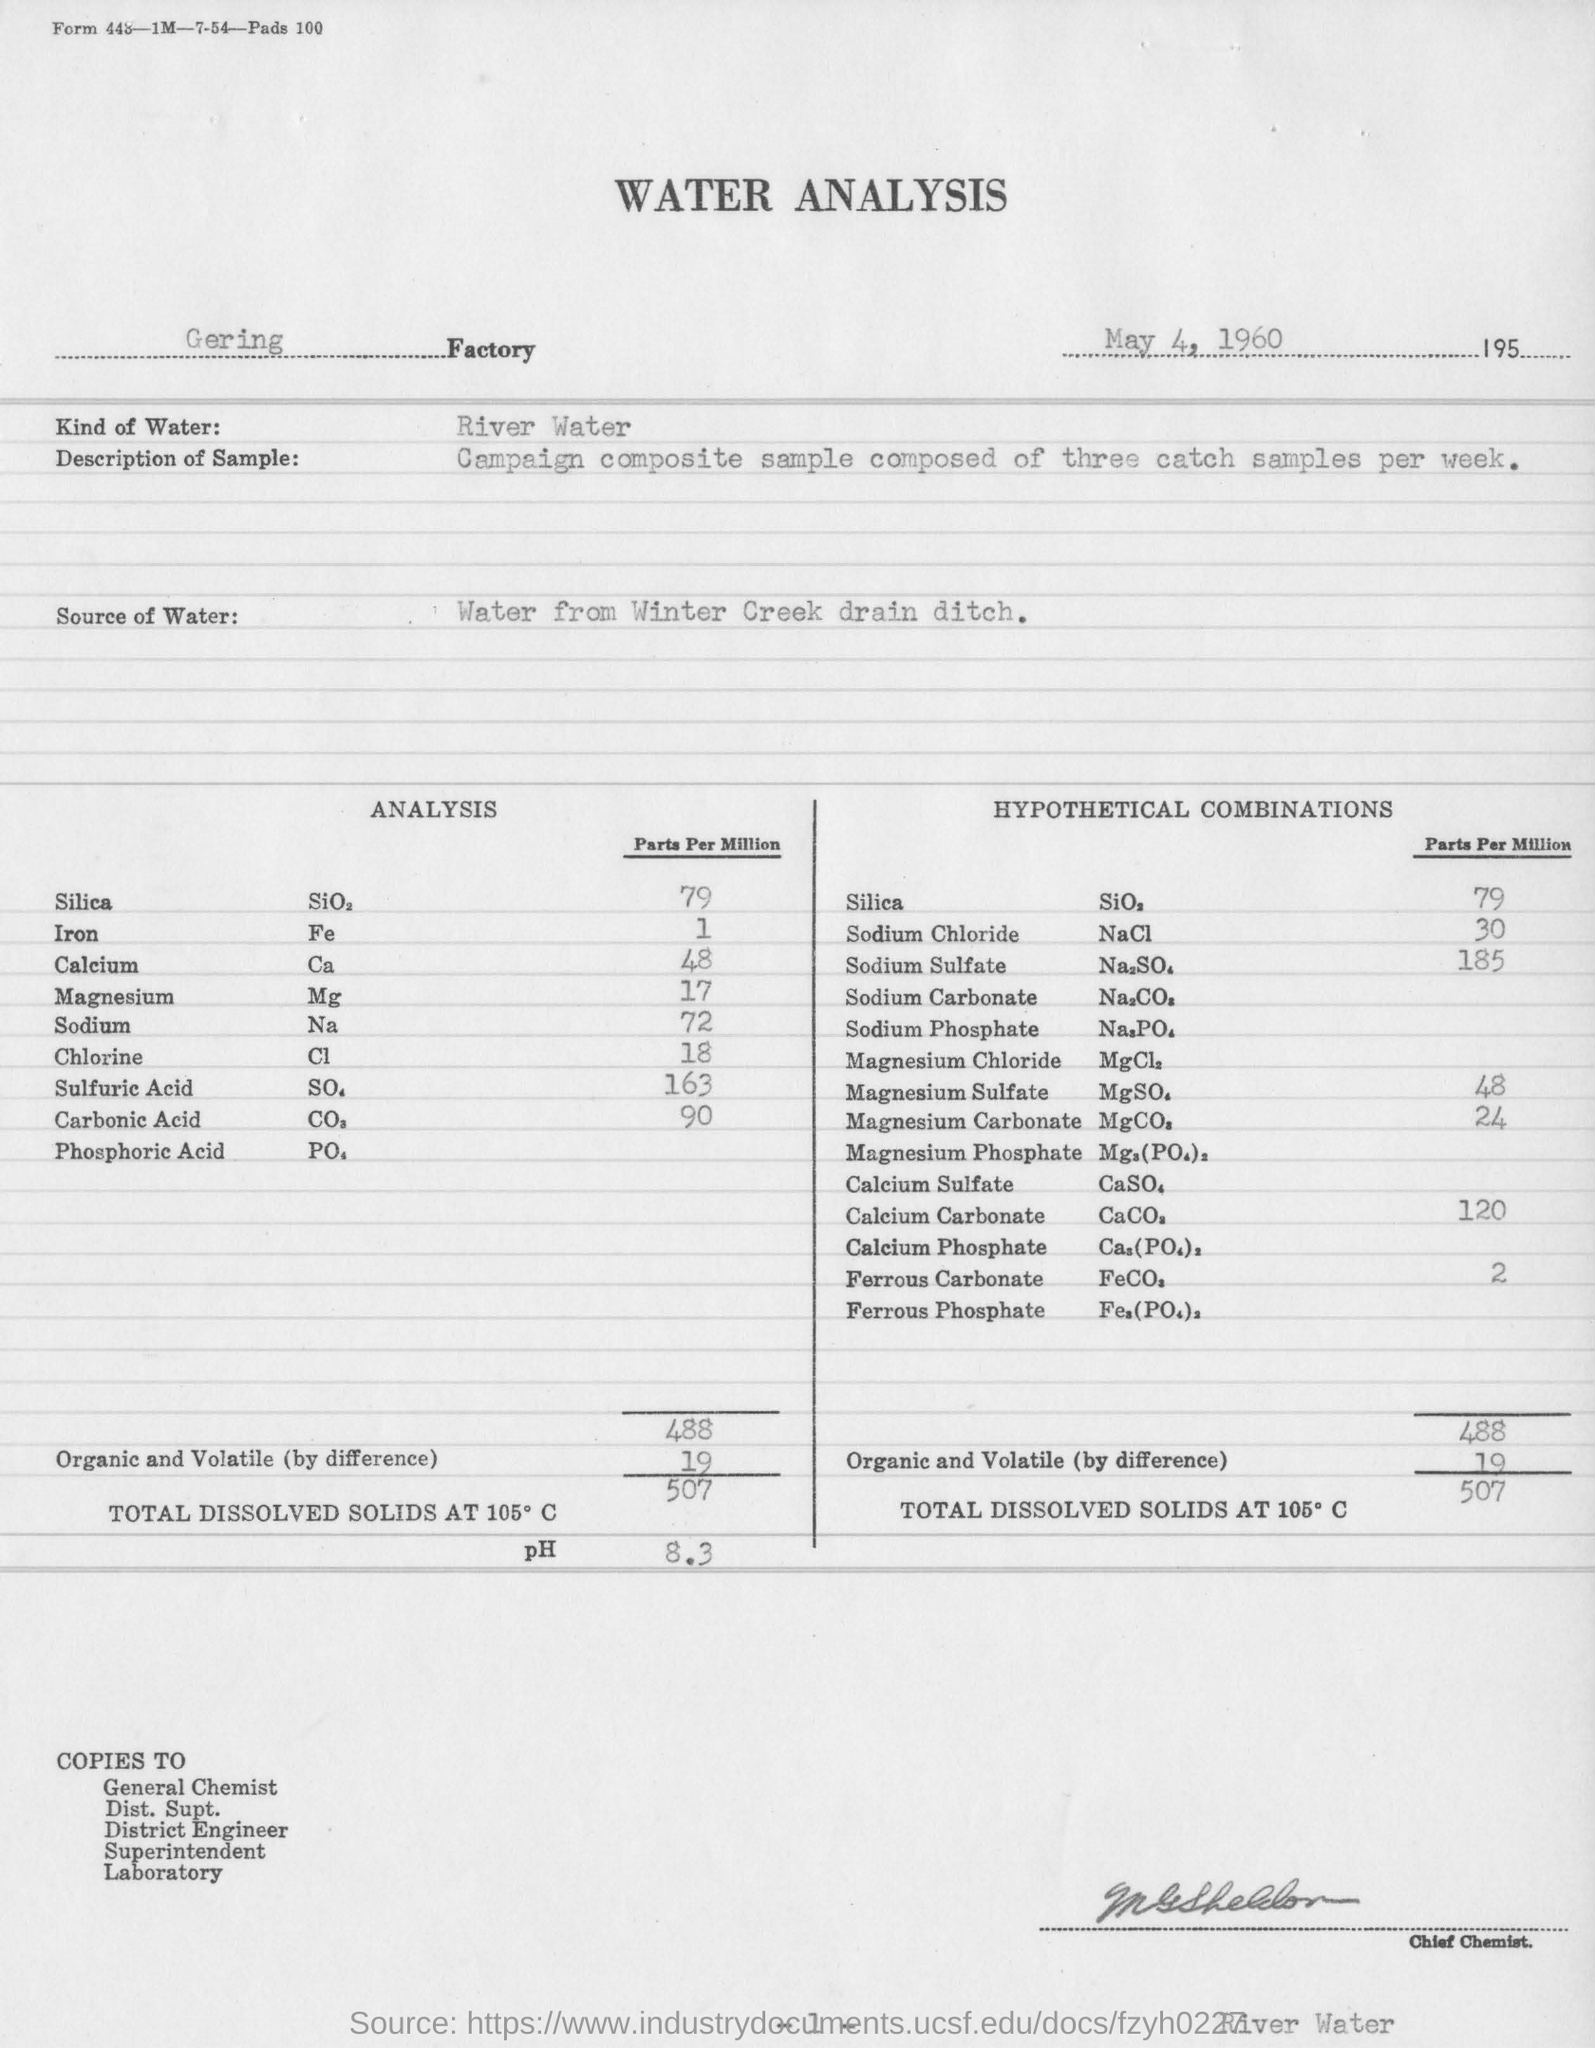On which date the water analysis is conducted ?
Your answer should be very brief. May 4, 1960. What kind of water is used in water analysis ?
Offer a terse response. River water. Name the factory in which the water analysis is conducted ?
Offer a terse response. Gering factory. Name the source of the water ?
Offer a very short reply. Water from Winter Creek drain ditch. What is the ph value obtained from the above water analysis ?
Offer a very short reply. 8.3. In hypothetical combinations what is the parts per million value of sodium chloride ?
Provide a succinct answer. 30. What is the amount of total dissolved solids at 105 degrees c ?
Ensure brevity in your answer.  507. In hypothetical combinations what is the parts per million value of silica ?
Keep it short and to the point. 79. In hypothetical combinations what is the parts per million value of sodium sulfate ?
Keep it short and to the point. 185. In hypothetical combinations what is the parts per million value of magnesium sulfate ?
Keep it short and to the point. 48. In hypothetical combinations what is the parts per million value of magnesium carbonate ?
Provide a short and direct response. 24. 